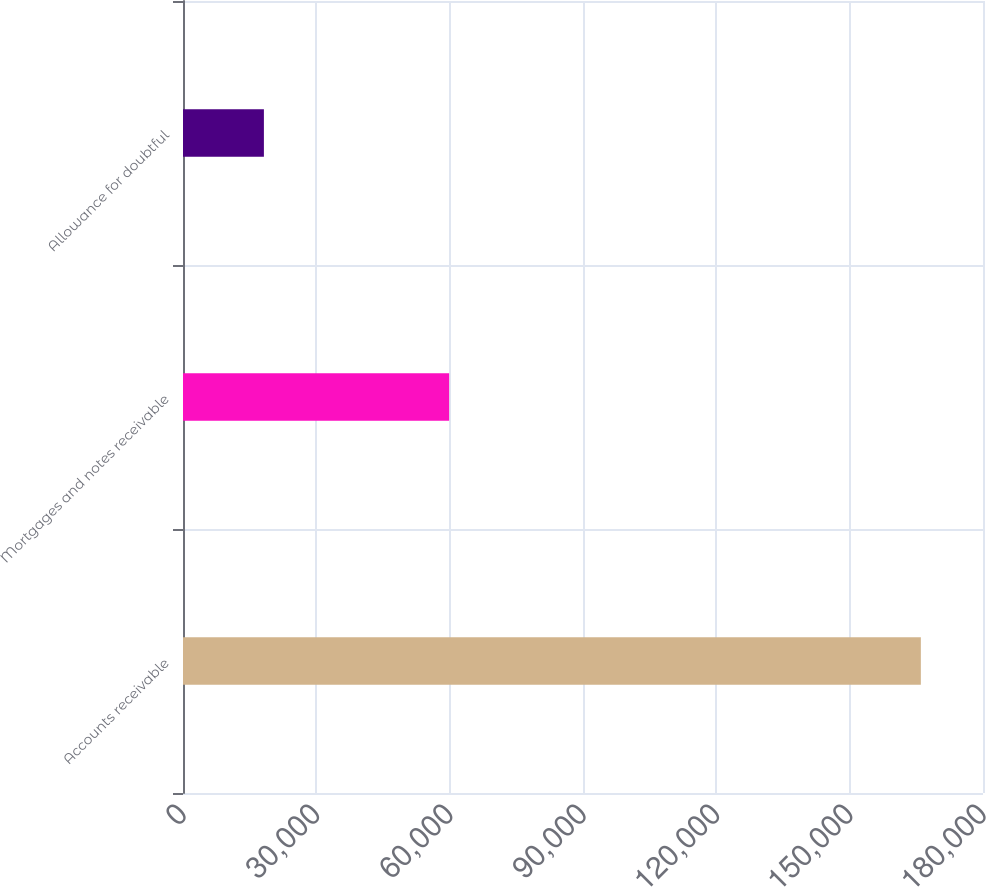Convert chart. <chart><loc_0><loc_0><loc_500><loc_500><bar_chart><fcel>Accounts receivable<fcel>Mortgages and notes receivable<fcel>Allowance for doubtful<nl><fcel>166017<fcel>59877<fcel>18203<nl></chart> 